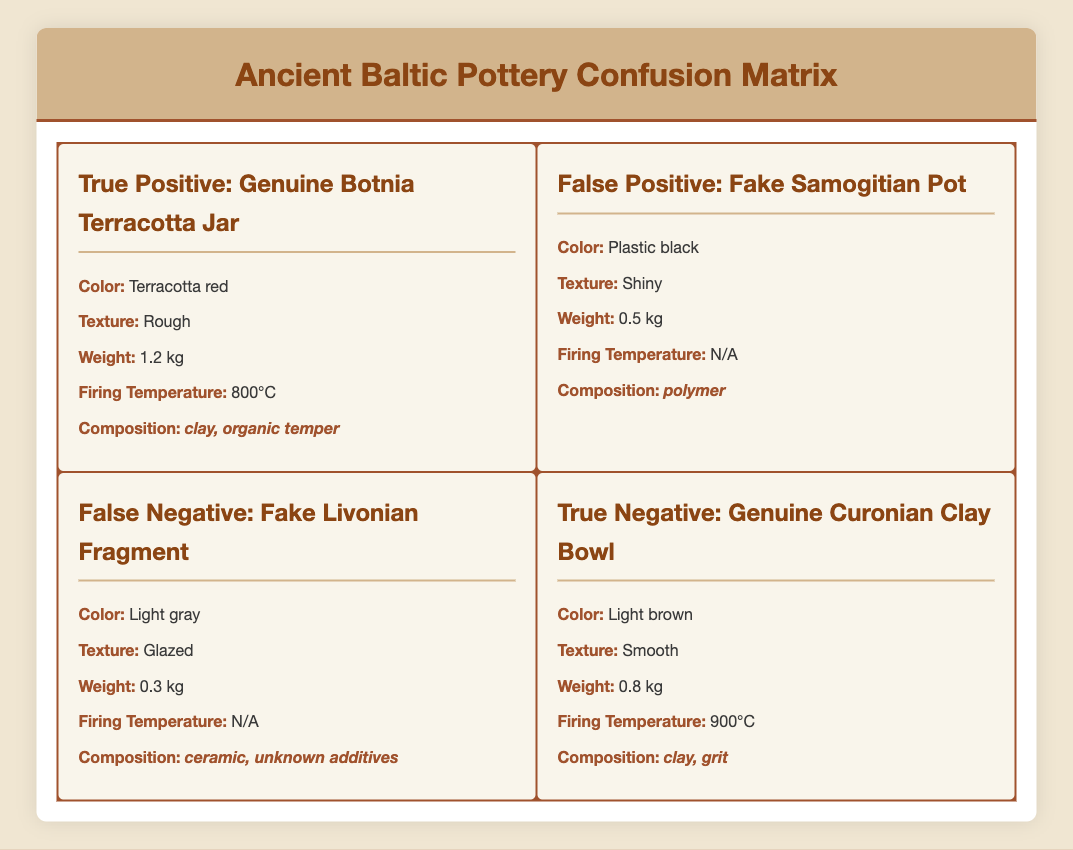What is the color of the genuine Botnia Terracotta Jar? The table lists the properties of the genuine Botnia Terracotta Jar, and it states that its color is "Terracotta red."
Answer: Terracotta red Which pottery example weighs more: the genuine Curonian Clay Bowl or the fake Livonian Fragment? The genuine Curonian Clay Bowl has a weight of 0.8 kg, while the fake Livonian Fragment weighs 0.3 kg. Since 0.8 kg is greater than 0.3 kg, the genuine Curonian Clay Bowl weighs more.
Answer: Genuine Curonian Clay Bowl Is the composition of the fake Samogitian Pot made of natural materials? The fake Samogitian Pot is composed of "polymer," which is a synthetic material, not a natural one. Therefore, the composition does not consist of natural materials.
Answer: No How many pottery examples have a firing temperature listed? The genuine Botnia Terracotta Jar lists a firing temperature of 800°C, the genuine Curonian Clay Bowl lists 900°C, while both the fake Samogitian Pot and fake Livonian Fragment do not have a firing temperature listed. Therefore, only 2 out of the 4 examples have a firing temperature listed.
Answer: 2 What is the difference in weight between the genuine Botnia Terracotta Jar and the fake Samogitian Pot? The genuine Botnia Terracotta Jar weighs 1.2 kg and the fake Samogitian Pot weighs 0.5 kg. The difference in weight is calculated as 1.2 kg - 0.5 kg, which equals 0.7 kg.
Answer: 0.7 kg Do both genuine pottery examples have a texture description, and if so, what are they? Yes, both genuine pottery examples (the Botnia Terracotta Jar and the Curonian Clay Bowl) have a texture description. The Botnia Terracotta Jar is "Rough," and the Curonian Clay Bowl is "Smooth."
Answer: Yes, Rough and Smooth Which pottery example has the highest firing temperature, and what is that temperature? Comparing the firing temperatures of the two genuine examples, the genuine Curonian Clay Bowl has the highest firing temperature at 900°C, while the genuine Botnia Terracotta Jar has 800°C. Therefore, the Curonian Clay Bowl has the highest.
Answer: Genuine Curonian Clay Bowl, 900°C If we average the weights of the two genuine pottery examples, what would be the result? The weights of the genuine examples are 1.2 kg (Botnia Terracotta Jar) and 0.8 kg (Curonian Clay Bowl). To find the average, we sum these weights (1.2 + 0.8 = 2.0 kg) and then divide by the number of genuine examples (2). The average weight is 2.0 kg / 2 = 1.0 kg.
Answer: 1.0 kg 